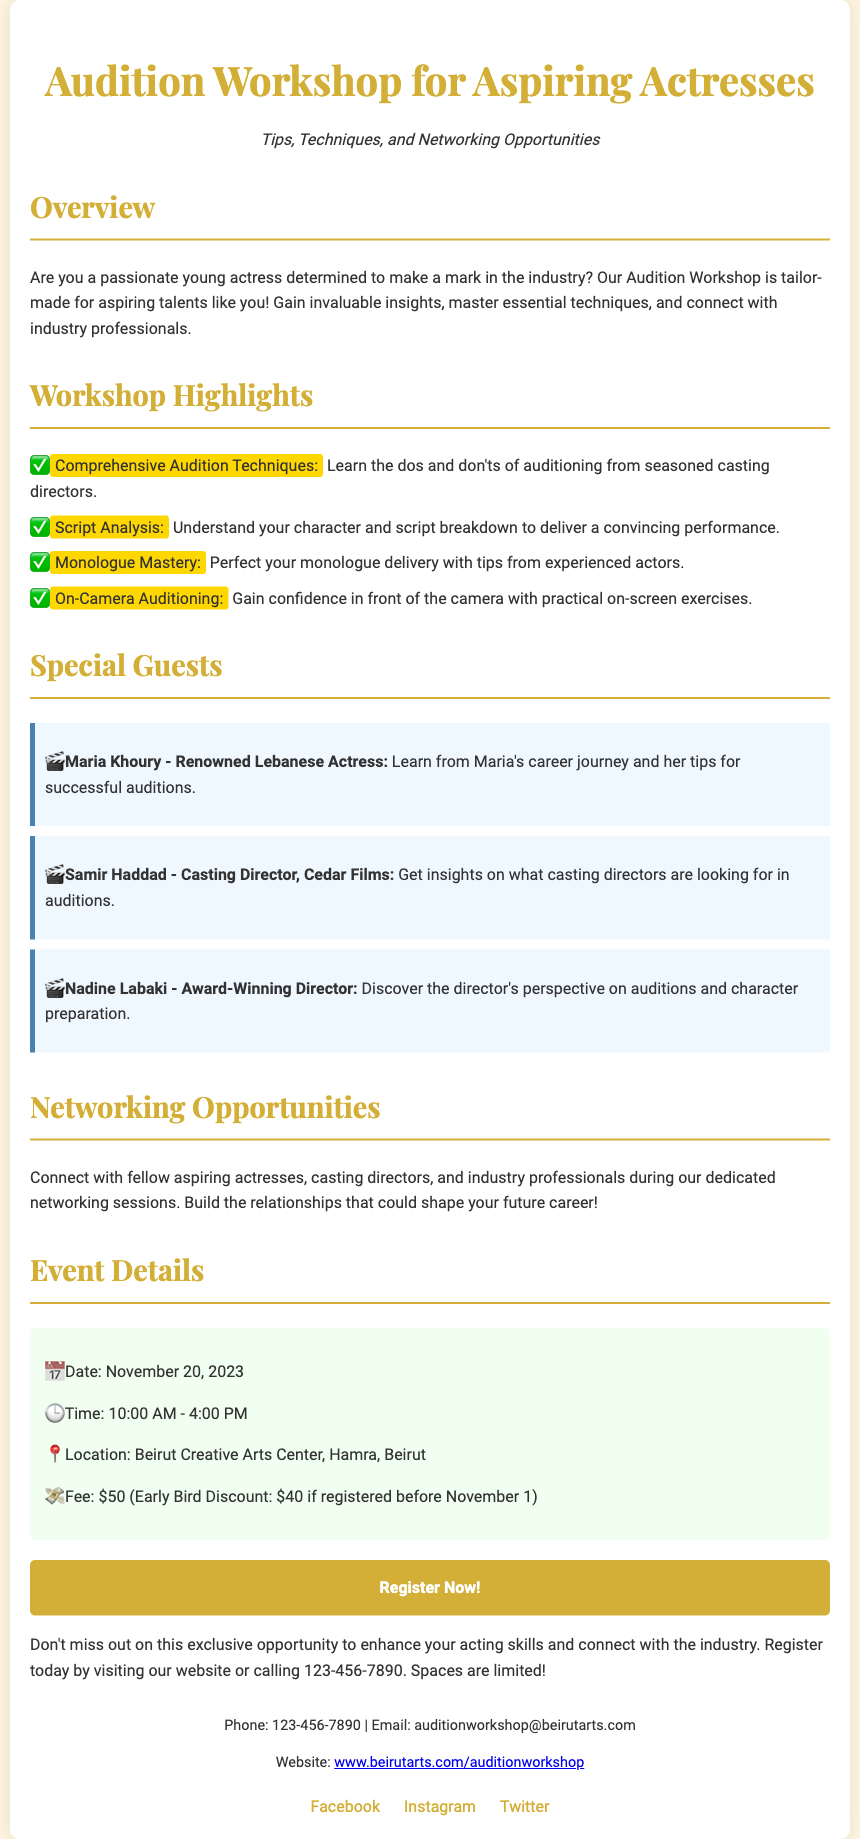What is the date of the workshop? The date of the workshop is presented clearly in the event details section.
Answer: November 20, 2023 What is the fee for the workshop? The document specifies the fee for attending the workshop, both regular and discounted prices.
Answer: $50 Who is a special guest at the workshop? The document lists several special guests, and asks for one of them to identify their participation.
Answer: Maria Khoury What is the time of the workshop? The workshop time is provided in the event details portion.
Answer: 10:00 AM - 4:00 PM What opportunity does the workshop provide beyond training? The workshop connects participants with others in the industry, which is highlighted in a specific section.
Answer: Networking opportunities What are participants expected to learn about monologues? The document outlines specific aspects of the workshop related to monologues.
Answer: Monologue mastery What is one benefit of the early bird discount? The document mentions a discount if registered before a specific date, indicating a benefit for early registration.
Answer: $40 Where is the workshop located? The location is detailed in the event details part of the document.
Answer: Beirut Creative Arts Center, Hamra, Beirut What is a unique feature of this document type? This type of document typically contains event highlights and details catered to specific audiences, enhancing engagement.
Answer: Customized content for aspiring actresses 